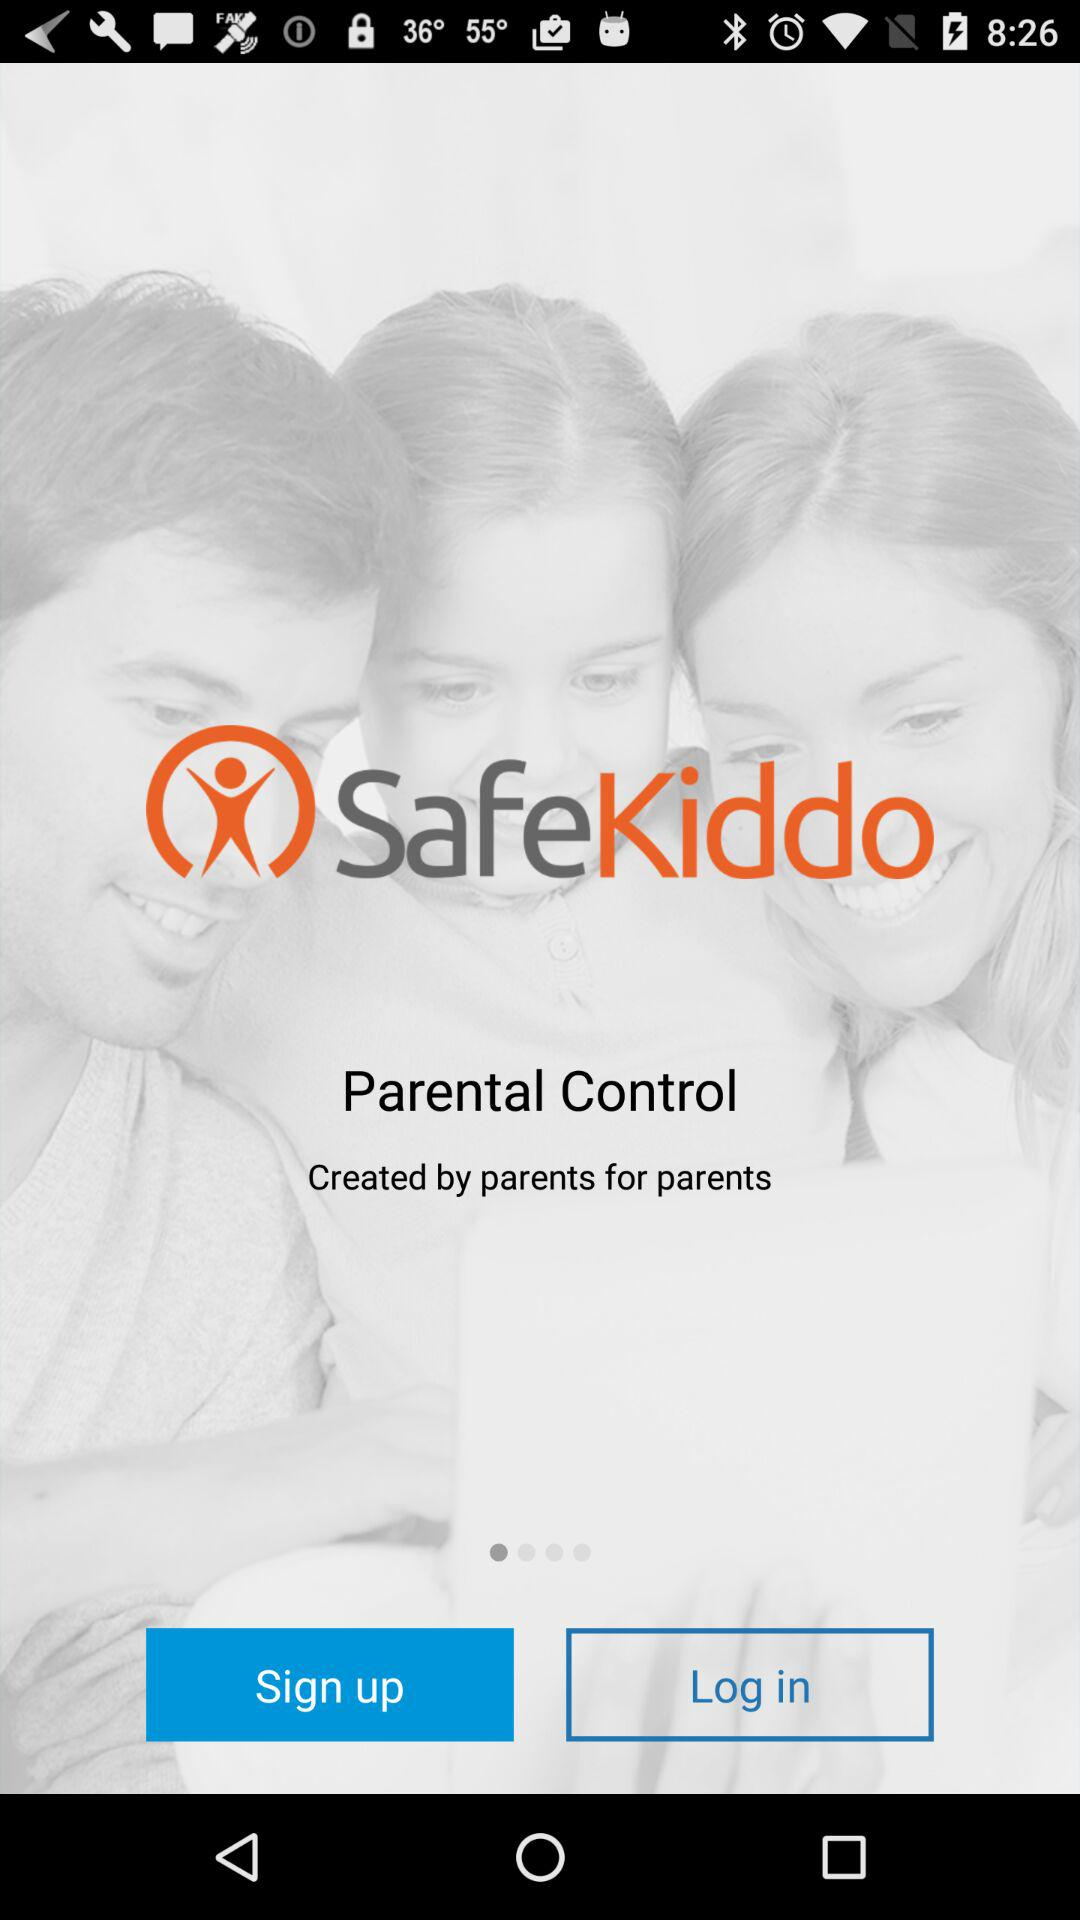What is the application name? The application name is "SafeKiddo". 